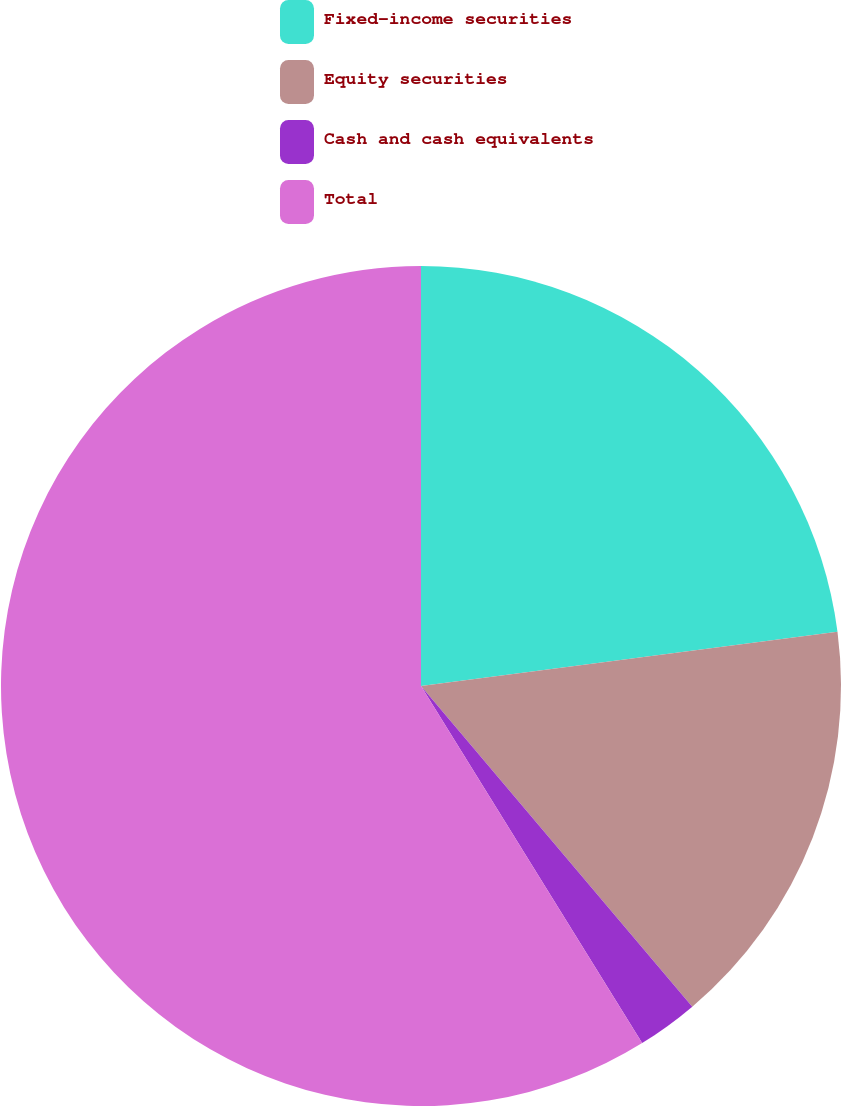Convert chart. <chart><loc_0><loc_0><loc_500><loc_500><pie_chart><fcel>Fixed-income securities<fcel>Equity securities<fcel>Cash and cash equivalents<fcel>Total<nl><fcel>22.94%<fcel>15.88%<fcel>2.35%<fcel>58.82%<nl></chart> 